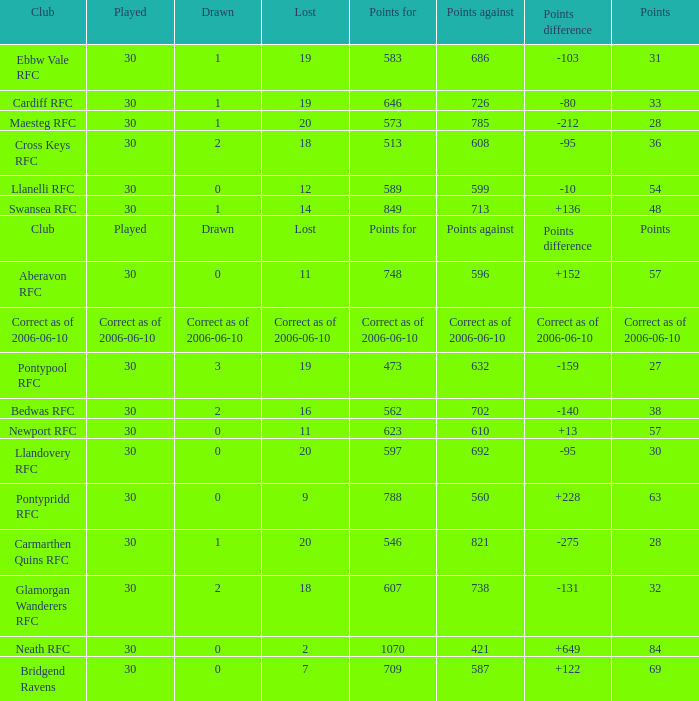What is Drawn, when Points Against is "686"? 1.0. 